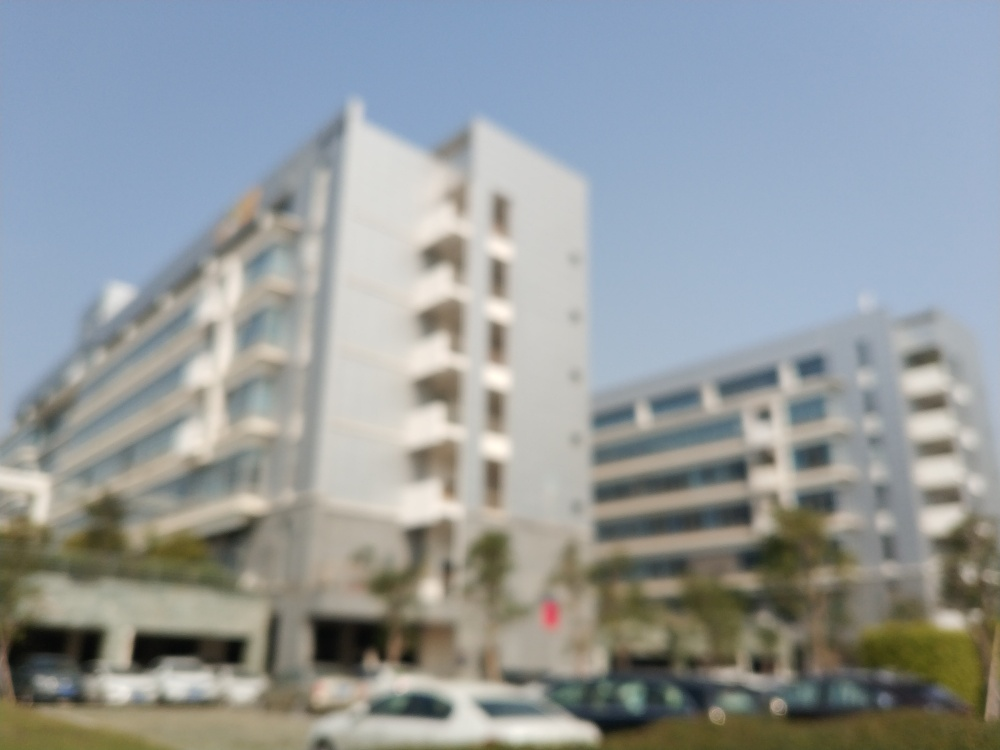Is the image free from noise?
A. No
B. Yes
Answer with the option's letter from the given choices directly.
 A. 